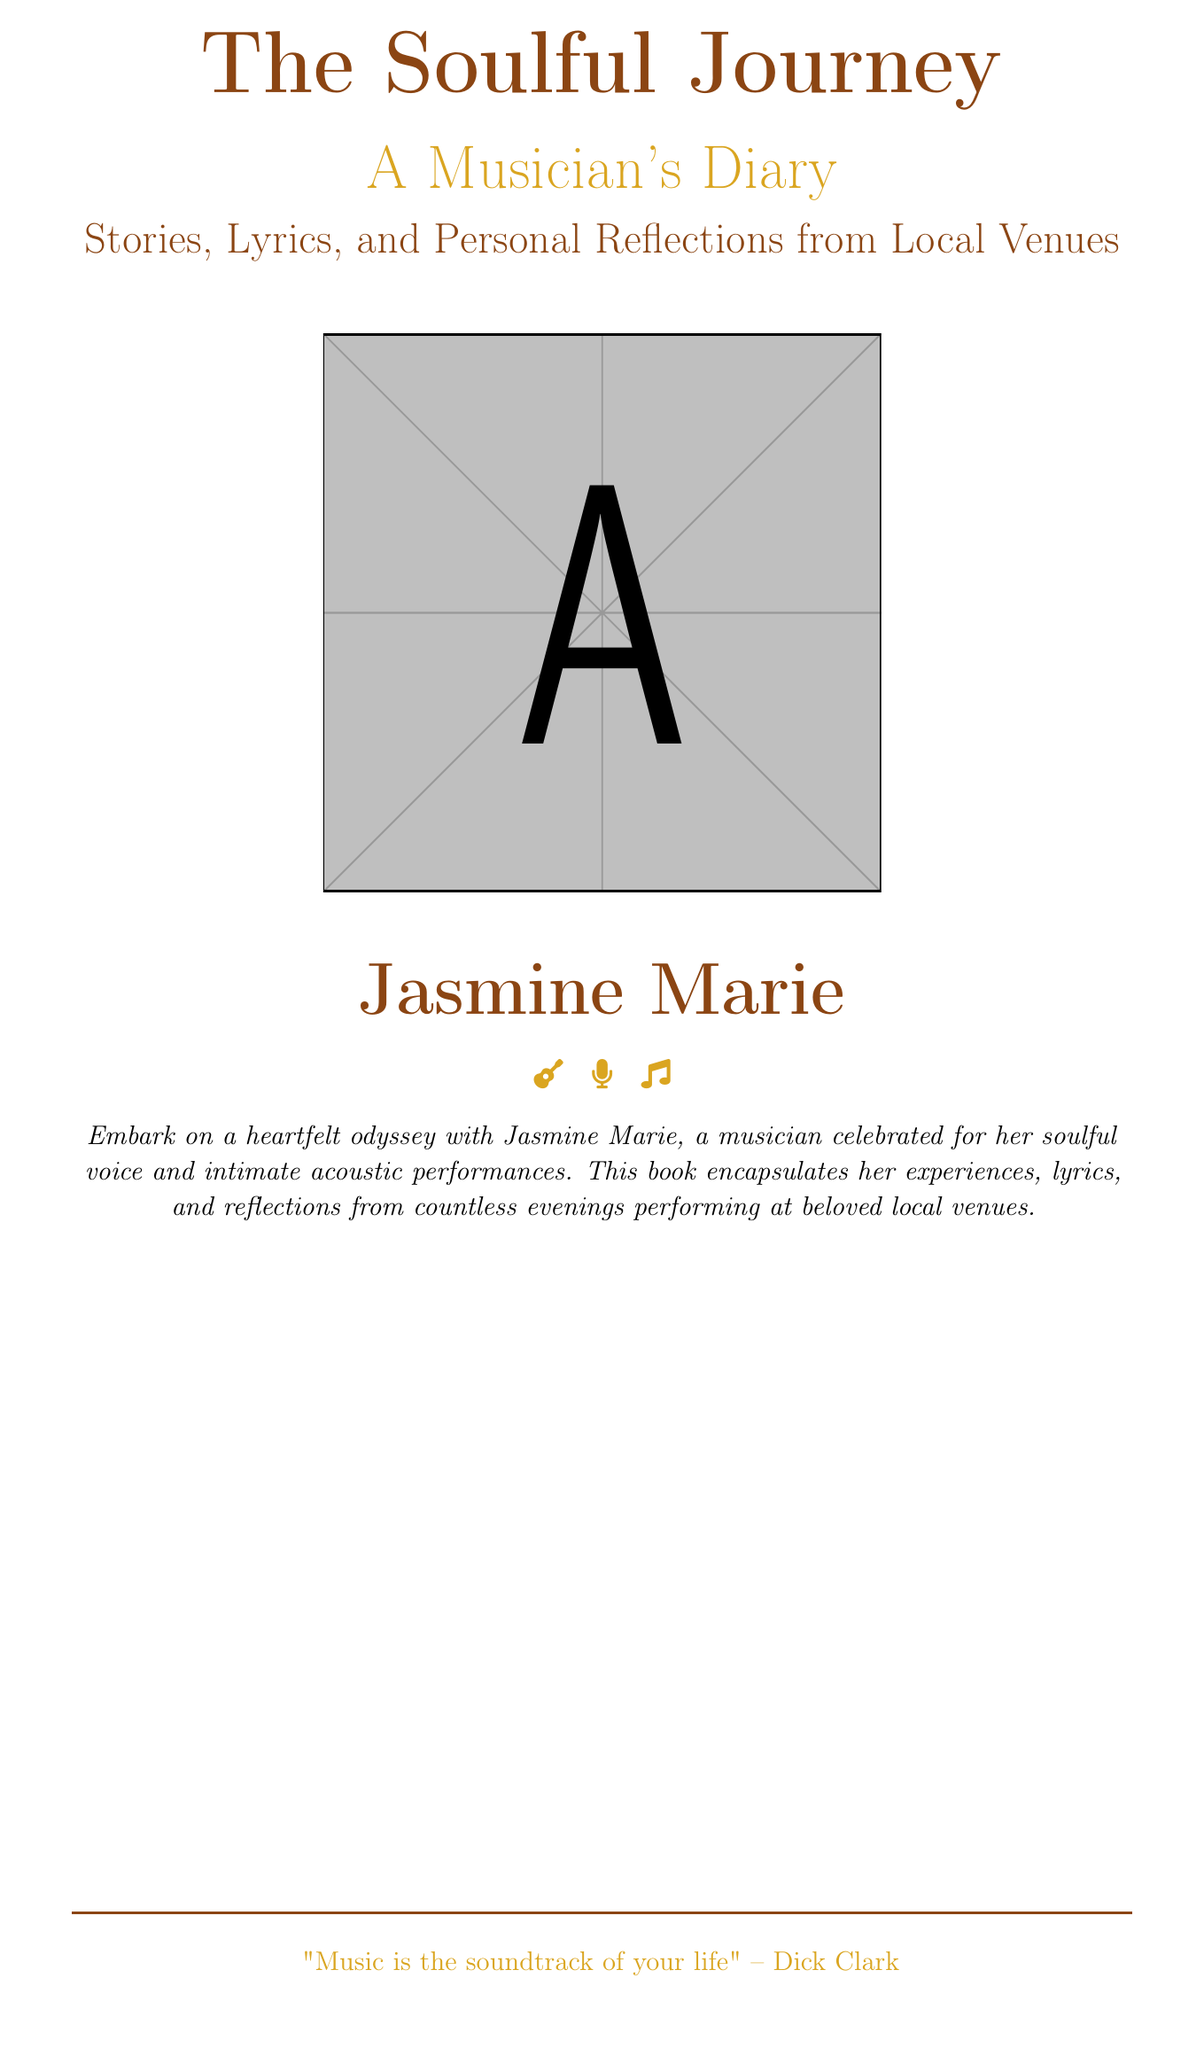What is the title of the book? The title is prominently displayed at the top of the document, which is "The Soulful Journey".
Answer: The Soulful Journey Who is the author of the book? The author's name is found at the bottom of the cover, which reads "Jasmine Marie".
Answer: Jasmine Marie What genre does the book represent? The diary format and musical themes suggest that it belongs to the memoir genre focused on music.
Answer: A Musician's Diary What color is used for the title? The color of the title can be seen and is a specific earthy hue identified as "soulful".
Answer: soulful What is included in the book along with stories? The cover mentions that the book includes lyrics and personal reflections in addition to stories.
Answer: Lyrics and personal reflections What is the main theme of the book? The main theme of the book centers around a musician's experiences and reflections during her performances.
Answer: A musician's heartfelt journey Which symbol is used to represent the author on the cover? The cover illustrates symbols related to music and performance, such as a guitar and microphone.
Answer: Guitar and microphone What quote is featured at the bottom of the cover? The quote provided at the bottom references the significance of music in life, specifically, "Music is the soundtrack of your life."
Answer: "Music is the soundtrack of your life" How does the author describe her performances? The author describes her performances as "intimate acoustic performances," suggesting a personal connection with the audience.
Answer: Intimate acoustic performances 